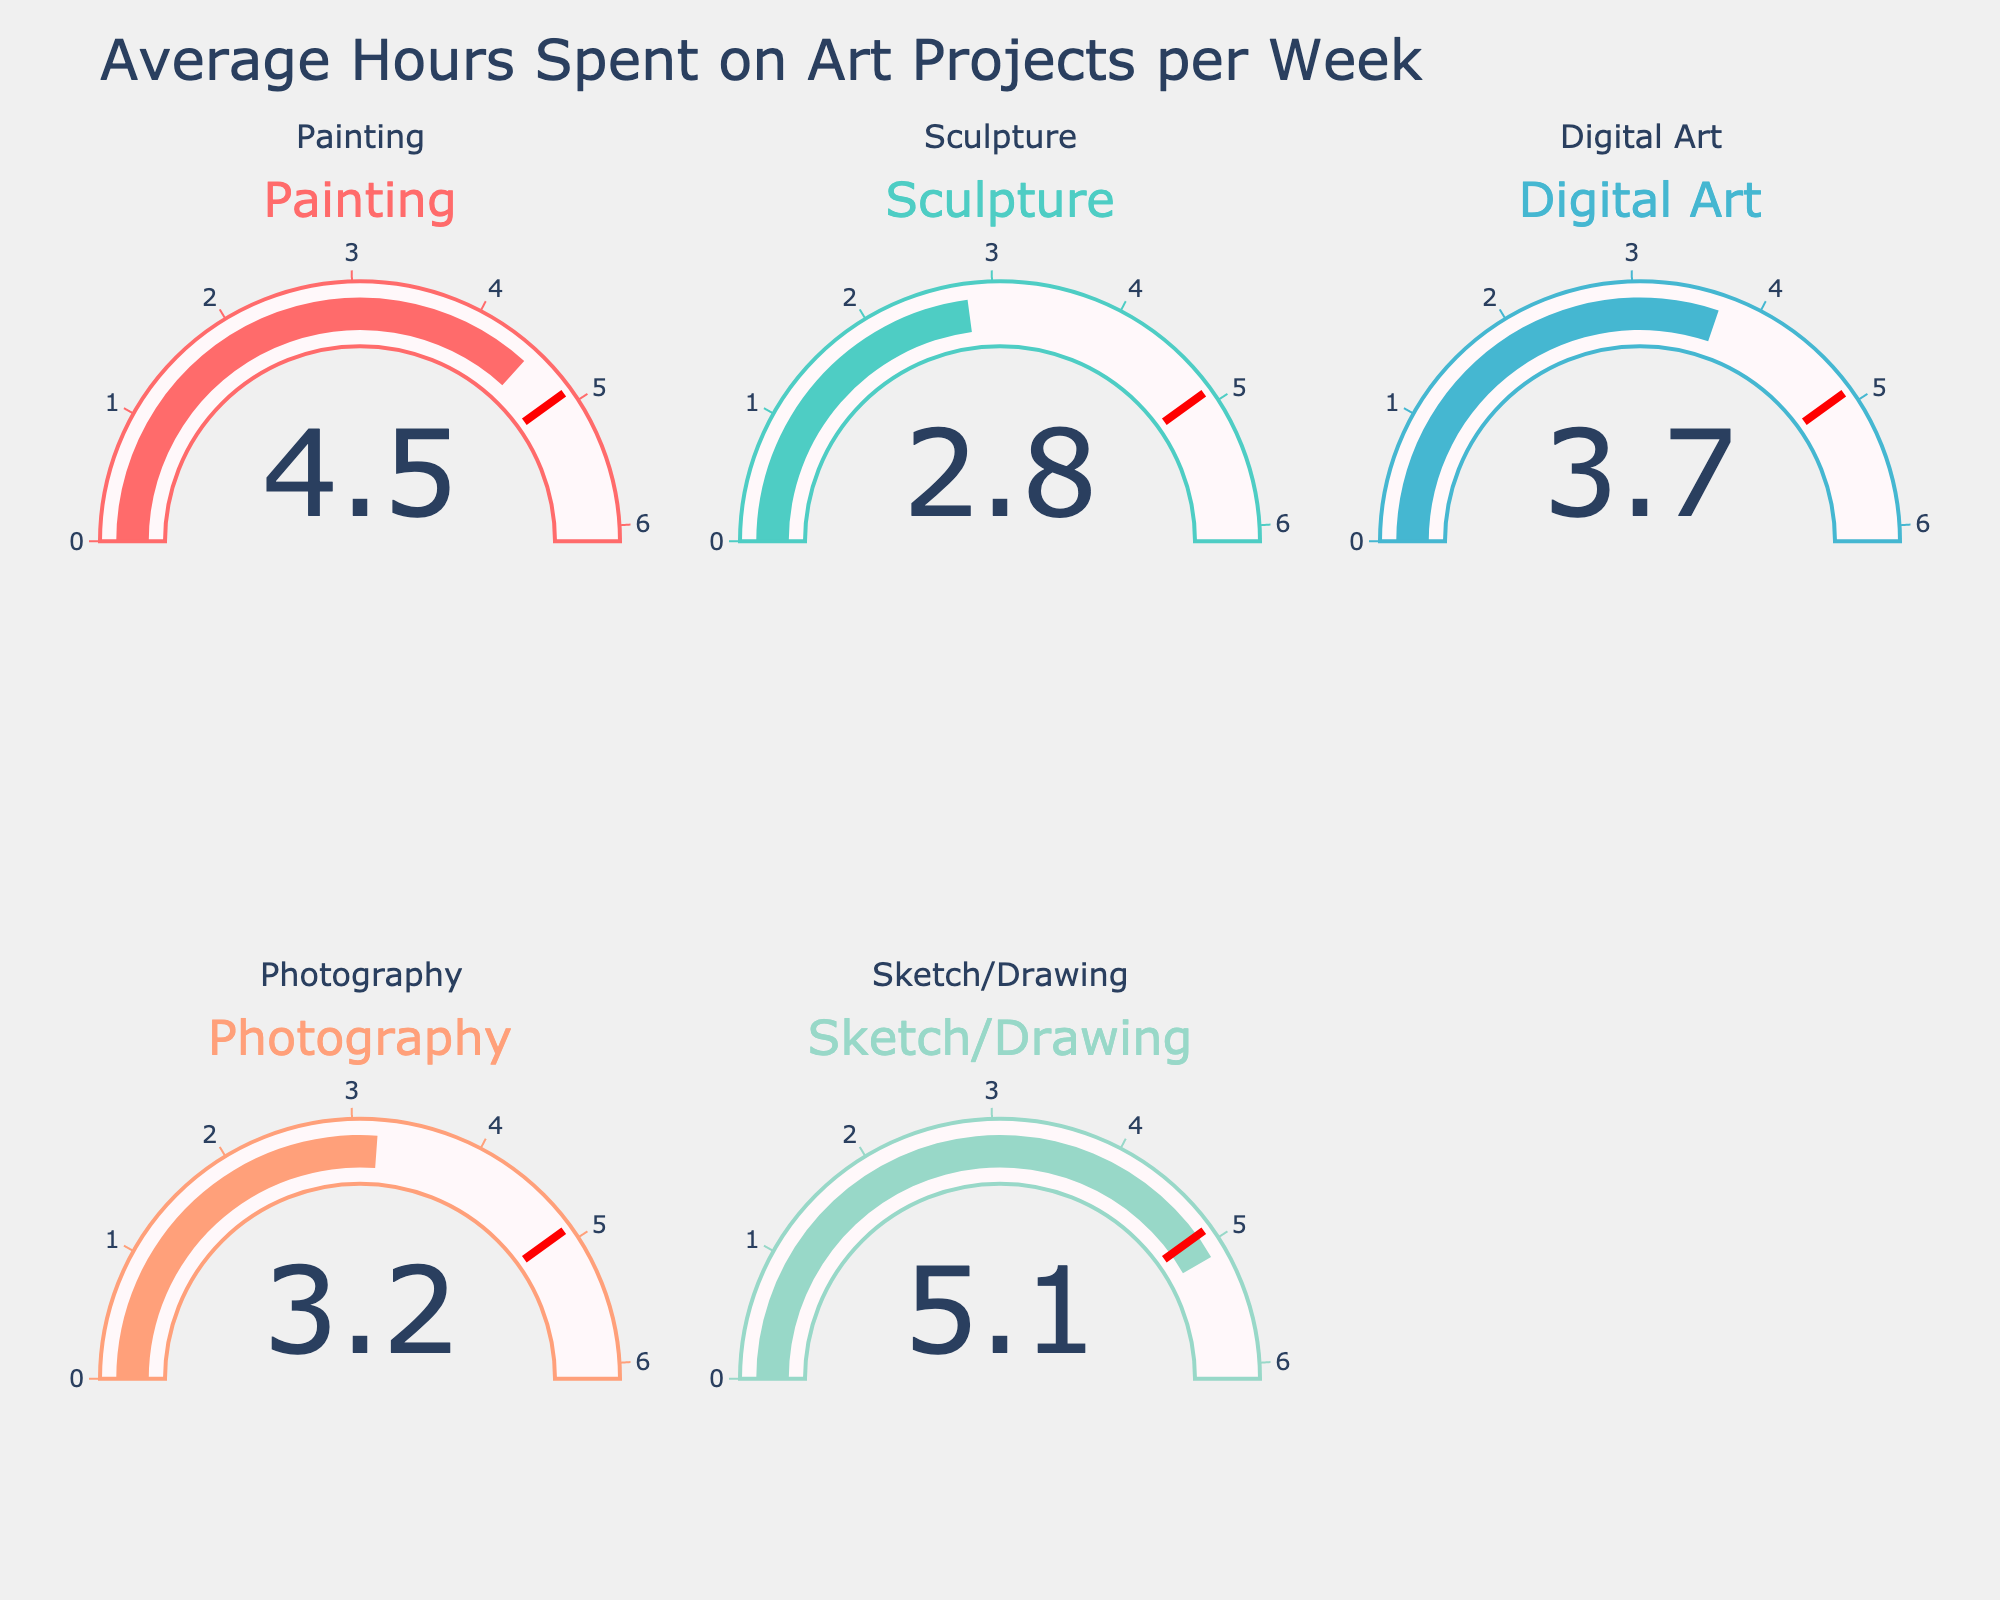What is the title of the figure? The title is usually found at the top center of the figure. In this case, it is displayed as "Average Hours Spent on Art Projects per Week".
Answer: Average Hours Spent on Art Projects per Week What category has the highest average hours spent per week? By comparing the values displayed on each gauge, the highest value is for Sketch/Drawing with 5.1 hours.
Answer: Sketch/Drawing What is the average number of hours spent on Digital Art and Photography combined? Add the hours spent on Digital Art (3.7) and Photography (3.2), then divide by 2 to get the average: (3.7 + 3.2) / 2 = 3.45.
Answer: 3.45 How do the hours spent on Painting compare to the hours spent on Sculpture? The hours spent on Painting are 4.5, and the hours spent on Sculpture are 2.8. Painting has more hours spent compared to Sculpture.
Answer: Painting has more hours spent Which activity has the lowest number of hours spent, and how many hours are spent on it? By looking at the values on the gauges, Sculpture has the lowest number of hours spent, which is 2.8 hours.
Answer: Sculpture, 2.8 hours What is the total number of hours spent on all activities combined? Sum all the values provided: 4.5 (Painting) + 2.8 (Sculpture) + 3.7 (Digital Art) + 3.2 (Photography) + 5.1 (Sketch/Drawing) = 19.3 hours.
Answer: 19.3 hours Is the number of hours spent on Photography greater than the average number of hours spent across all activities? First, find the average number of hours spent across all activities: (4.5 + 2.8 + 3.7 + 3.2 + 5.1) / 5 = 3.86. Then compare it to Photography's hours (3.2). Photography has less than the average.
Answer: No, Photography has less than the average What is the difference in hours spent on Sketch/Drawing and Digital Art? Subtract Digital Art hours from Sketch/Drawing hours: 5.1 - 3.7 = 1.4 hours.
Answer: 1.4 hours What percentage of the total hours is spent on Painting? First, find the total hours (19.3). Then, calculate the percentage for Painting: (4.5 / 19.3) * 100 ≈ 23.32%.
Answer: 23.32% What is the range of hours spent on all the activities? The range is the difference between the maximum and minimum values. Maximum is 5.1 (Sketch/Drawing) and minimum is 2.8 (Sculpture). So, 5.1 - 2.8 = 2.3 hours.
Answer: 2.3 hours 